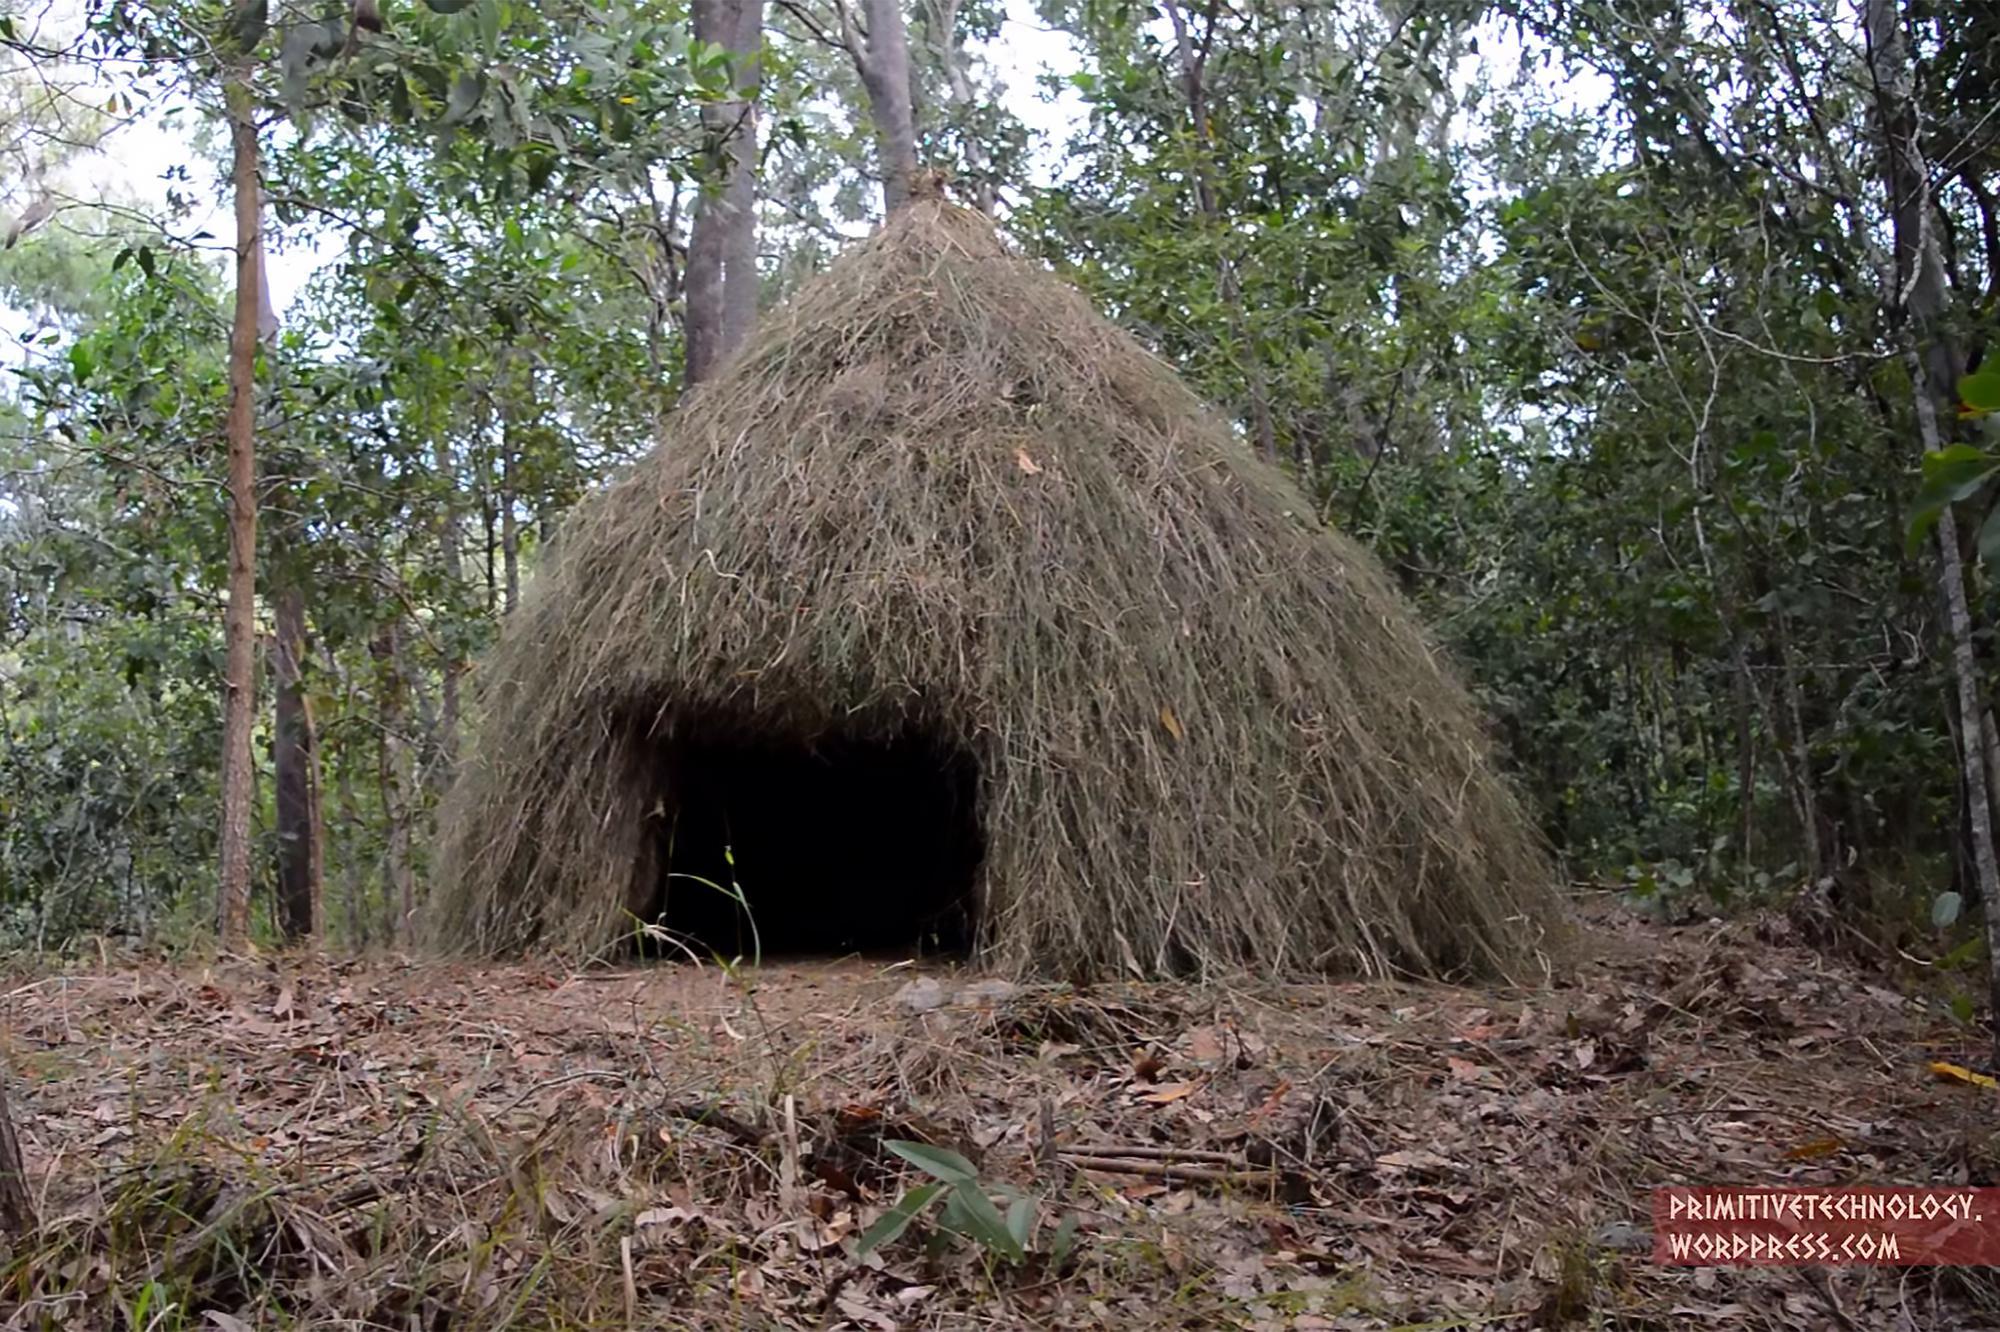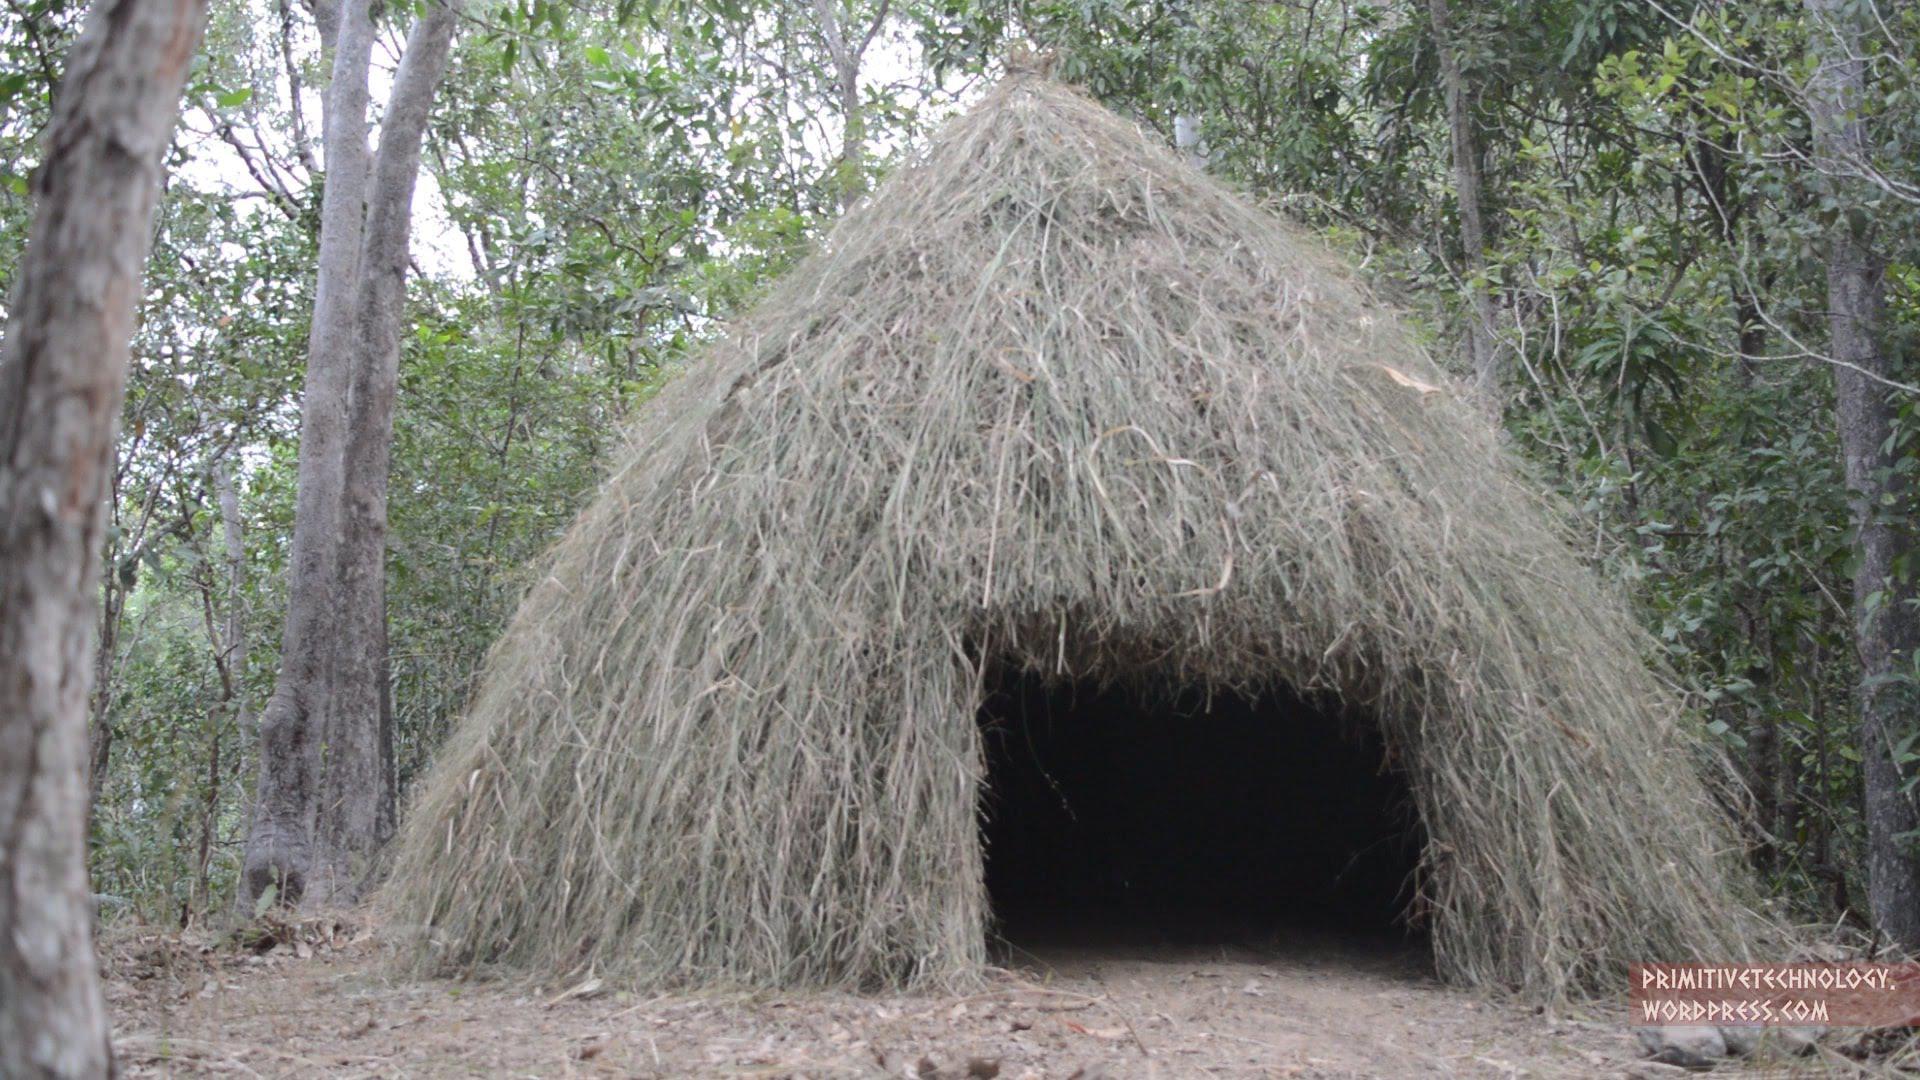The first image is the image on the left, the second image is the image on the right. Given the left and right images, does the statement "At least one of the images contains a simple structure with a wide door opening and thick thatching that covers the whole structure." hold true? Answer yes or no. Yes. The first image is the image on the left, the second image is the image on the right. For the images displayed, is the sentence "None of the shelters have a door." factually correct? Answer yes or no. Yes. 